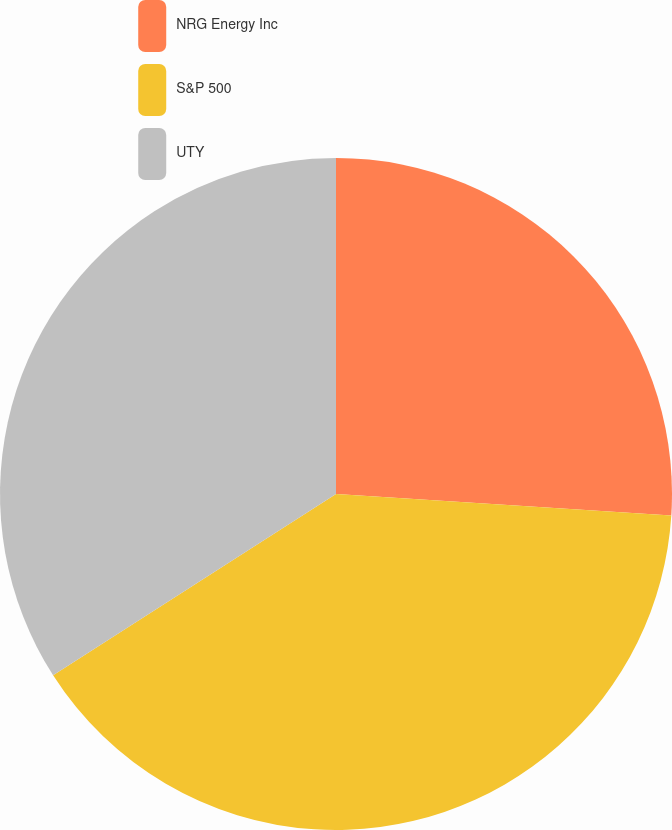<chart> <loc_0><loc_0><loc_500><loc_500><pie_chart><fcel>NRG Energy Inc<fcel>S&P 500<fcel>UTY<nl><fcel>26.02%<fcel>39.91%<fcel>34.07%<nl></chart> 